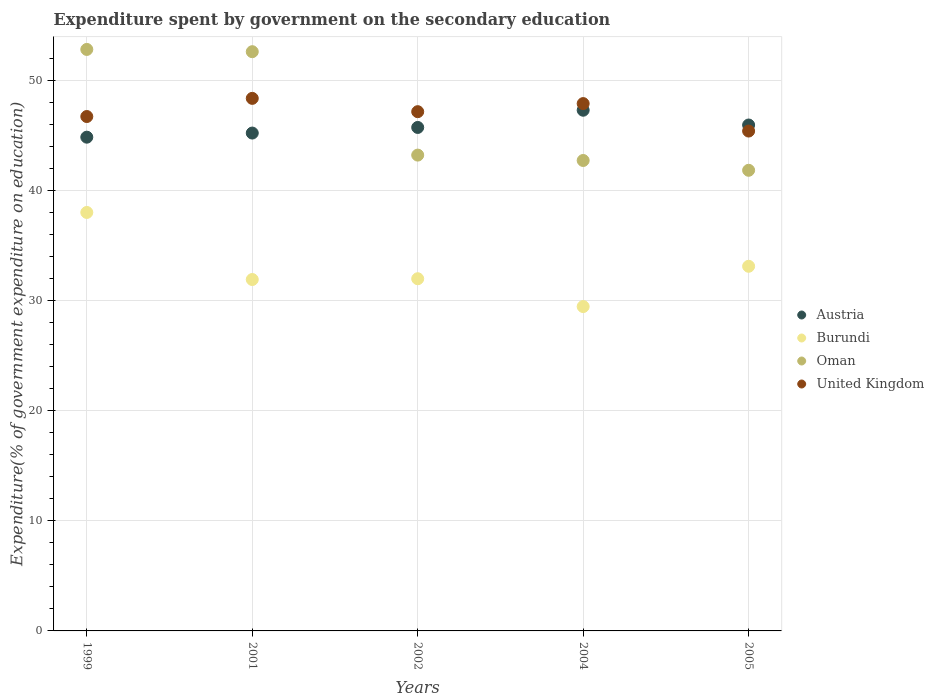How many different coloured dotlines are there?
Ensure brevity in your answer.  4. Is the number of dotlines equal to the number of legend labels?
Your answer should be very brief. Yes. What is the expenditure spent by government on the secondary education in United Kingdom in 2004?
Provide a short and direct response. 47.88. Across all years, what is the maximum expenditure spent by government on the secondary education in Burundi?
Offer a terse response. 38. Across all years, what is the minimum expenditure spent by government on the secondary education in United Kingdom?
Provide a succinct answer. 45.39. What is the total expenditure spent by government on the secondary education in Oman in the graph?
Provide a succinct answer. 233.14. What is the difference between the expenditure spent by government on the secondary education in Burundi in 2001 and that in 2005?
Provide a succinct answer. -1.2. What is the difference between the expenditure spent by government on the secondary education in Oman in 2002 and the expenditure spent by government on the secondary education in Austria in 2005?
Offer a terse response. -2.73. What is the average expenditure spent by government on the secondary education in United Kingdom per year?
Your answer should be very brief. 47.1. In the year 2005, what is the difference between the expenditure spent by government on the secondary education in Oman and expenditure spent by government on the secondary education in Austria?
Make the answer very short. -4.11. In how many years, is the expenditure spent by government on the secondary education in Burundi greater than 12 %?
Give a very brief answer. 5. What is the ratio of the expenditure spent by government on the secondary education in United Kingdom in 2001 to that in 2004?
Offer a terse response. 1.01. What is the difference between the highest and the second highest expenditure spent by government on the secondary education in United Kingdom?
Provide a short and direct response. 0.47. What is the difference between the highest and the lowest expenditure spent by government on the secondary education in Oman?
Give a very brief answer. 10.97. In how many years, is the expenditure spent by government on the secondary education in Burundi greater than the average expenditure spent by government on the secondary education in Burundi taken over all years?
Your answer should be very brief. 2. Is the sum of the expenditure spent by government on the secondary education in Austria in 1999 and 2005 greater than the maximum expenditure spent by government on the secondary education in Oman across all years?
Your answer should be compact. Yes. Is it the case that in every year, the sum of the expenditure spent by government on the secondary education in United Kingdom and expenditure spent by government on the secondary education in Burundi  is greater than the expenditure spent by government on the secondary education in Austria?
Give a very brief answer. Yes. Is the expenditure spent by government on the secondary education in Austria strictly greater than the expenditure spent by government on the secondary education in United Kingdom over the years?
Offer a terse response. No. Is the expenditure spent by government on the secondary education in Austria strictly less than the expenditure spent by government on the secondary education in Burundi over the years?
Your response must be concise. No. How many dotlines are there?
Give a very brief answer. 4. How many years are there in the graph?
Your answer should be very brief. 5. What is the difference between two consecutive major ticks on the Y-axis?
Make the answer very short. 10. Are the values on the major ticks of Y-axis written in scientific E-notation?
Your answer should be compact. No. Does the graph contain any zero values?
Offer a very short reply. No. Does the graph contain grids?
Offer a terse response. Yes. How many legend labels are there?
Your response must be concise. 4. How are the legend labels stacked?
Ensure brevity in your answer.  Vertical. What is the title of the graph?
Provide a succinct answer. Expenditure spent by government on the secondary education. What is the label or title of the X-axis?
Ensure brevity in your answer.  Years. What is the label or title of the Y-axis?
Make the answer very short. Expenditure(% of government expenditure on education). What is the Expenditure(% of government expenditure on education) of Austria in 1999?
Your answer should be compact. 44.83. What is the Expenditure(% of government expenditure on education) in Burundi in 1999?
Ensure brevity in your answer.  38. What is the Expenditure(% of government expenditure on education) in Oman in 1999?
Ensure brevity in your answer.  52.8. What is the Expenditure(% of government expenditure on education) in United Kingdom in 1999?
Offer a terse response. 46.71. What is the Expenditure(% of government expenditure on education) of Austria in 2001?
Keep it short and to the point. 45.21. What is the Expenditure(% of government expenditure on education) of Burundi in 2001?
Provide a succinct answer. 31.91. What is the Expenditure(% of government expenditure on education) of Oman in 2001?
Give a very brief answer. 52.59. What is the Expenditure(% of government expenditure on education) of United Kingdom in 2001?
Give a very brief answer. 48.36. What is the Expenditure(% of government expenditure on education) in Austria in 2002?
Your answer should be compact. 45.72. What is the Expenditure(% of government expenditure on education) of Burundi in 2002?
Offer a terse response. 31.98. What is the Expenditure(% of government expenditure on education) of Oman in 2002?
Ensure brevity in your answer.  43.21. What is the Expenditure(% of government expenditure on education) of United Kingdom in 2002?
Your response must be concise. 47.15. What is the Expenditure(% of government expenditure on education) in Austria in 2004?
Give a very brief answer. 47.28. What is the Expenditure(% of government expenditure on education) in Burundi in 2004?
Your answer should be compact. 29.45. What is the Expenditure(% of government expenditure on education) of Oman in 2004?
Offer a terse response. 42.72. What is the Expenditure(% of government expenditure on education) in United Kingdom in 2004?
Your response must be concise. 47.88. What is the Expenditure(% of government expenditure on education) of Austria in 2005?
Keep it short and to the point. 45.94. What is the Expenditure(% of government expenditure on education) of Burundi in 2005?
Ensure brevity in your answer.  33.11. What is the Expenditure(% of government expenditure on education) of Oman in 2005?
Your response must be concise. 41.83. What is the Expenditure(% of government expenditure on education) in United Kingdom in 2005?
Provide a short and direct response. 45.39. Across all years, what is the maximum Expenditure(% of government expenditure on education) of Austria?
Your response must be concise. 47.28. Across all years, what is the maximum Expenditure(% of government expenditure on education) in Burundi?
Offer a very short reply. 38. Across all years, what is the maximum Expenditure(% of government expenditure on education) in Oman?
Provide a short and direct response. 52.8. Across all years, what is the maximum Expenditure(% of government expenditure on education) in United Kingdom?
Make the answer very short. 48.36. Across all years, what is the minimum Expenditure(% of government expenditure on education) in Austria?
Your answer should be very brief. 44.83. Across all years, what is the minimum Expenditure(% of government expenditure on education) in Burundi?
Make the answer very short. 29.45. Across all years, what is the minimum Expenditure(% of government expenditure on education) in Oman?
Your answer should be very brief. 41.83. Across all years, what is the minimum Expenditure(% of government expenditure on education) of United Kingdom?
Ensure brevity in your answer.  45.39. What is the total Expenditure(% of government expenditure on education) of Austria in the graph?
Offer a very short reply. 228.97. What is the total Expenditure(% of government expenditure on education) in Burundi in the graph?
Your answer should be compact. 164.45. What is the total Expenditure(% of government expenditure on education) in Oman in the graph?
Ensure brevity in your answer.  233.14. What is the total Expenditure(% of government expenditure on education) of United Kingdom in the graph?
Your response must be concise. 235.48. What is the difference between the Expenditure(% of government expenditure on education) of Austria in 1999 and that in 2001?
Provide a short and direct response. -0.37. What is the difference between the Expenditure(% of government expenditure on education) of Burundi in 1999 and that in 2001?
Provide a succinct answer. 6.09. What is the difference between the Expenditure(% of government expenditure on education) of Oman in 1999 and that in 2001?
Your answer should be very brief. 0.21. What is the difference between the Expenditure(% of government expenditure on education) in United Kingdom in 1999 and that in 2001?
Your answer should be compact. -1.65. What is the difference between the Expenditure(% of government expenditure on education) in Austria in 1999 and that in 2002?
Make the answer very short. -0.88. What is the difference between the Expenditure(% of government expenditure on education) of Burundi in 1999 and that in 2002?
Your answer should be very brief. 6.02. What is the difference between the Expenditure(% of government expenditure on education) in Oman in 1999 and that in 2002?
Provide a short and direct response. 9.59. What is the difference between the Expenditure(% of government expenditure on education) in United Kingdom in 1999 and that in 2002?
Provide a succinct answer. -0.44. What is the difference between the Expenditure(% of government expenditure on education) in Austria in 1999 and that in 2004?
Give a very brief answer. -2.45. What is the difference between the Expenditure(% of government expenditure on education) in Burundi in 1999 and that in 2004?
Your response must be concise. 8.54. What is the difference between the Expenditure(% of government expenditure on education) in Oman in 1999 and that in 2004?
Your response must be concise. 10.08. What is the difference between the Expenditure(% of government expenditure on education) in United Kingdom in 1999 and that in 2004?
Keep it short and to the point. -1.17. What is the difference between the Expenditure(% of government expenditure on education) in Austria in 1999 and that in 2005?
Offer a very short reply. -1.1. What is the difference between the Expenditure(% of government expenditure on education) in Burundi in 1999 and that in 2005?
Your answer should be very brief. 4.89. What is the difference between the Expenditure(% of government expenditure on education) of Oman in 1999 and that in 2005?
Make the answer very short. 10.97. What is the difference between the Expenditure(% of government expenditure on education) of United Kingdom in 1999 and that in 2005?
Offer a very short reply. 1.32. What is the difference between the Expenditure(% of government expenditure on education) in Austria in 2001 and that in 2002?
Give a very brief answer. -0.51. What is the difference between the Expenditure(% of government expenditure on education) of Burundi in 2001 and that in 2002?
Provide a succinct answer. -0.07. What is the difference between the Expenditure(% of government expenditure on education) of Oman in 2001 and that in 2002?
Ensure brevity in your answer.  9.39. What is the difference between the Expenditure(% of government expenditure on education) of United Kingdom in 2001 and that in 2002?
Offer a very short reply. 1.21. What is the difference between the Expenditure(% of government expenditure on education) of Austria in 2001 and that in 2004?
Give a very brief answer. -2.07. What is the difference between the Expenditure(% of government expenditure on education) of Burundi in 2001 and that in 2004?
Keep it short and to the point. 2.46. What is the difference between the Expenditure(% of government expenditure on education) in Oman in 2001 and that in 2004?
Your response must be concise. 9.88. What is the difference between the Expenditure(% of government expenditure on education) in United Kingdom in 2001 and that in 2004?
Your answer should be compact. 0.47. What is the difference between the Expenditure(% of government expenditure on education) of Austria in 2001 and that in 2005?
Ensure brevity in your answer.  -0.73. What is the difference between the Expenditure(% of government expenditure on education) in Burundi in 2001 and that in 2005?
Offer a very short reply. -1.2. What is the difference between the Expenditure(% of government expenditure on education) of Oman in 2001 and that in 2005?
Your response must be concise. 10.77. What is the difference between the Expenditure(% of government expenditure on education) of United Kingdom in 2001 and that in 2005?
Your answer should be compact. 2.97. What is the difference between the Expenditure(% of government expenditure on education) of Austria in 2002 and that in 2004?
Offer a terse response. -1.56. What is the difference between the Expenditure(% of government expenditure on education) of Burundi in 2002 and that in 2004?
Give a very brief answer. 2.53. What is the difference between the Expenditure(% of government expenditure on education) of Oman in 2002 and that in 2004?
Offer a terse response. 0.49. What is the difference between the Expenditure(% of government expenditure on education) of United Kingdom in 2002 and that in 2004?
Your answer should be very brief. -0.73. What is the difference between the Expenditure(% of government expenditure on education) in Austria in 2002 and that in 2005?
Keep it short and to the point. -0.22. What is the difference between the Expenditure(% of government expenditure on education) of Burundi in 2002 and that in 2005?
Provide a short and direct response. -1.13. What is the difference between the Expenditure(% of government expenditure on education) of Oman in 2002 and that in 2005?
Your answer should be very brief. 1.38. What is the difference between the Expenditure(% of government expenditure on education) of United Kingdom in 2002 and that in 2005?
Offer a very short reply. 1.76. What is the difference between the Expenditure(% of government expenditure on education) in Austria in 2004 and that in 2005?
Ensure brevity in your answer.  1.34. What is the difference between the Expenditure(% of government expenditure on education) in Burundi in 2004 and that in 2005?
Provide a short and direct response. -3.66. What is the difference between the Expenditure(% of government expenditure on education) of Oman in 2004 and that in 2005?
Your answer should be compact. 0.89. What is the difference between the Expenditure(% of government expenditure on education) of United Kingdom in 2004 and that in 2005?
Ensure brevity in your answer.  2.49. What is the difference between the Expenditure(% of government expenditure on education) in Austria in 1999 and the Expenditure(% of government expenditure on education) in Burundi in 2001?
Make the answer very short. 12.92. What is the difference between the Expenditure(% of government expenditure on education) of Austria in 1999 and the Expenditure(% of government expenditure on education) of Oman in 2001?
Offer a terse response. -7.76. What is the difference between the Expenditure(% of government expenditure on education) in Austria in 1999 and the Expenditure(% of government expenditure on education) in United Kingdom in 2001?
Offer a very short reply. -3.52. What is the difference between the Expenditure(% of government expenditure on education) in Burundi in 1999 and the Expenditure(% of government expenditure on education) in Oman in 2001?
Your answer should be compact. -14.6. What is the difference between the Expenditure(% of government expenditure on education) in Burundi in 1999 and the Expenditure(% of government expenditure on education) in United Kingdom in 2001?
Provide a short and direct response. -10.36. What is the difference between the Expenditure(% of government expenditure on education) in Oman in 1999 and the Expenditure(% of government expenditure on education) in United Kingdom in 2001?
Give a very brief answer. 4.44. What is the difference between the Expenditure(% of government expenditure on education) in Austria in 1999 and the Expenditure(% of government expenditure on education) in Burundi in 2002?
Make the answer very short. 12.85. What is the difference between the Expenditure(% of government expenditure on education) of Austria in 1999 and the Expenditure(% of government expenditure on education) of Oman in 2002?
Provide a short and direct response. 1.63. What is the difference between the Expenditure(% of government expenditure on education) in Austria in 1999 and the Expenditure(% of government expenditure on education) in United Kingdom in 2002?
Your response must be concise. -2.32. What is the difference between the Expenditure(% of government expenditure on education) in Burundi in 1999 and the Expenditure(% of government expenditure on education) in Oman in 2002?
Your answer should be very brief. -5.21. What is the difference between the Expenditure(% of government expenditure on education) in Burundi in 1999 and the Expenditure(% of government expenditure on education) in United Kingdom in 2002?
Make the answer very short. -9.15. What is the difference between the Expenditure(% of government expenditure on education) of Oman in 1999 and the Expenditure(% of government expenditure on education) of United Kingdom in 2002?
Make the answer very short. 5.65. What is the difference between the Expenditure(% of government expenditure on education) of Austria in 1999 and the Expenditure(% of government expenditure on education) of Burundi in 2004?
Give a very brief answer. 15.38. What is the difference between the Expenditure(% of government expenditure on education) in Austria in 1999 and the Expenditure(% of government expenditure on education) in Oman in 2004?
Offer a very short reply. 2.12. What is the difference between the Expenditure(% of government expenditure on education) of Austria in 1999 and the Expenditure(% of government expenditure on education) of United Kingdom in 2004?
Your answer should be very brief. -3.05. What is the difference between the Expenditure(% of government expenditure on education) in Burundi in 1999 and the Expenditure(% of government expenditure on education) in Oman in 2004?
Offer a terse response. -4.72. What is the difference between the Expenditure(% of government expenditure on education) of Burundi in 1999 and the Expenditure(% of government expenditure on education) of United Kingdom in 2004?
Provide a short and direct response. -9.88. What is the difference between the Expenditure(% of government expenditure on education) of Oman in 1999 and the Expenditure(% of government expenditure on education) of United Kingdom in 2004?
Provide a short and direct response. 4.92. What is the difference between the Expenditure(% of government expenditure on education) of Austria in 1999 and the Expenditure(% of government expenditure on education) of Burundi in 2005?
Give a very brief answer. 11.72. What is the difference between the Expenditure(% of government expenditure on education) in Austria in 1999 and the Expenditure(% of government expenditure on education) in Oman in 2005?
Keep it short and to the point. 3.01. What is the difference between the Expenditure(% of government expenditure on education) of Austria in 1999 and the Expenditure(% of government expenditure on education) of United Kingdom in 2005?
Offer a terse response. -0.56. What is the difference between the Expenditure(% of government expenditure on education) of Burundi in 1999 and the Expenditure(% of government expenditure on education) of Oman in 2005?
Keep it short and to the point. -3.83. What is the difference between the Expenditure(% of government expenditure on education) of Burundi in 1999 and the Expenditure(% of government expenditure on education) of United Kingdom in 2005?
Provide a succinct answer. -7.39. What is the difference between the Expenditure(% of government expenditure on education) in Oman in 1999 and the Expenditure(% of government expenditure on education) in United Kingdom in 2005?
Provide a succinct answer. 7.41. What is the difference between the Expenditure(% of government expenditure on education) of Austria in 2001 and the Expenditure(% of government expenditure on education) of Burundi in 2002?
Your answer should be compact. 13.23. What is the difference between the Expenditure(% of government expenditure on education) of Austria in 2001 and the Expenditure(% of government expenditure on education) of Oman in 2002?
Provide a short and direct response. 2. What is the difference between the Expenditure(% of government expenditure on education) in Austria in 2001 and the Expenditure(% of government expenditure on education) in United Kingdom in 2002?
Offer a terse response. -1.94. What is the difference between the Expenditure(% of government expenditure on education) of Burundi in 2001 and the Expenditure(% of government expenditure on education) of Oman in 2002?
Ensure brevity in your answer.  -11.3. What is the difference between the Expenditure(% of government expenditure on education) of Burundi in 2001 and the Expenditure(% of government expenditure on education) of United Kingdom in 2002?
Provide a short and direct response. -15.24. What is the difference between the Expenditure(% of government expenditure on education) in Oman in 2001 and the Expenditure(% of government expenditure on education) in United Kingdom in 2002?
Your response must be concise. 5.45. What is the difference between the Expenditure(% of government expenditure on education) in Austria in 2001 and the Expenditure(% of government expenditure on education) in Burundi in 2004?
Give a very brief answer. 15.75. What is the difference between the Expenditure(% of government expenditure on education) of Austria in 2001 and the Expenditure(% of government expenditure on education) of Oman in 2004?
Make the answer very short. 2.49. What is the difference between the Expenditure(% of government expenditure on education) in Austria in 2001 and the Expenditure(% of government expenditure on education) in United Kingdom in 2004?
Your response must be concise. -2.68. What is the difference between the Expenditure(% of government expenditure on education) of Burundi in 2001 and the Expenditure(% of government expenditure on education) of Oman in 2004?
Your answer should be compact. -10.81. What is the difference between the Expenditure(% of government expenditure on education) in Burundi in 2001 and the Expenditure(% of government expenditure on education) in United Kingdom in 2004?
Provide a succinct answer. -15.97. What is the difference between the Expenditure(% of government expenditure on education) of Oman in 2001 and the Expenditure(% of government expenditure on education) of United Kingdom in 2004?
Make the answer very short. 4.71. What is the difference between the Expenditure(% of government expenditure on education) in Austria in 2001 and the Expenditure(% of government expenditure on education) in Burundi in 2005?
Offer a terse response. 12.1. What is the difference between the Expenditure(% of government expenditure on education) of Austria in 2001 and the Expenditure(% of government expenditure on education) of Oman in 2005?
Your answer should be very brief. 3.38. What is the difference between the Expenditure(% of government expenditure on education) of Austria in 2001 and the Expenditure(% of government expenditure on education) of United Kingdom in 2005?
Make the answer very short. -0.18. What is the difference between the Expenditure(% of government expenditure on education) of Burundi in 2001 and the Expenditure(% of government expenditure on education) of Oman in 2005?
Provide a short and direct response. -9.92. What is the difference between the Expenditure(% of government expenditure on education) of Burundi in 2001 and the Expenditure(% of government expenditure on education) of United Kingdom in 2005?
Give a very brief answer. -13.48. What is the difference between the Expenditure(% of government expenditure on education) in Oman in 2001 and the Expenditure(% of government expenditure on education) in United Kingdom in 2005?
Your answer should be compact. 7.21. What is the difference between the Expenditure(% of government expenditure on education) of Austria in 2002 and the Expenditure(% of government expenditure on education) of Burundi in 2004?
Offer a terse response. 16.26. What is the difference between the Expenditure(% of government expenditure on education) of Austria in 2002 and the Expenditure(% of government expenditure on education) of Oman in 2004?
Keep it short and to the point. 3. What is the difference between the Expenditure(% of government expenditure on education) in Austria in 2002 and the Expenditure(% of government expenditure on education) in United Kingdom in 2004?
Give a very brief answer. -2.17. What is the difference between the Expenditure(% of government expenditure on education) in Burundi in 2002 and the Expenditure(% of government expenditure on education) in Oman in 2004?
Make the answer very short. -10.74. What is the difference between the Expenditure(% of government expenditure on education) of Burundi in 2002 and the Expenditure(% of government expenditure on education) of United Kingdom in 2004?
Keep it short and to the point. -15.9. What is the difference between the Expenditure(% of government expenditure on education) in Oman in 2002 and the Expenditure(% of government expenditure on education) in United Kingdom in 2004?
Keep it short and to the point. -4.68. What is the difference between the Expenditure(% of government expenditure on education) in Austria in 2002 and the Expenditure(% of government expenditure on education) in Burundi in 2005?
Your answer should be compact. 12.61. What is the difference between the Expenditure(% of government expenditure on education) of Austria in 2002 and the Expenditure(% of government expenditure on education) of Oman in 2005?
Give a very brief answer. 3.89. What is the difference between the Expenditure(% of government expenditure on education) of Austria in 2002 and the Expenditure(% of government expenditure on education) of United Kingdom in 2005?
Provide a short and direct response. 0.33. What is the difference between the Expenditure(% of government expenditure on education) of Burundi in 2002 and the Expenditure(% of government expenditure on education) of Oman in 2005?
Give a very brief answer. -9.85. What is the difference between the Expenditure(% of government expenditure on education) of Burundi in 2002 and the Expenditure(% of government expenditure on education) of United Kingdom in 2005?
Provide a succinct answer. -13.41. What is the difference between the Expenditure(% of government expenditure on education) in Oman in 2002 and the Expenditure(% of government expenditure on education) in United Kingdom in 2005?
Make the answer very short. -2.18. What is the difference between the Expenditure(% of government expenditure on education) in Austria in 2004 and the Expenditure(% of government expenditure on education) in Burundi in 2005?
Make the answer very short. 14.17. What is the difference between the Expenditure(% of government expenditure on education) of Austria in 2004 and the Expenditure(% of government expenditure on education) of Oman in 2005?
Your response must be concise. 5.45. What is the difference between the Expenditure(% of government expenditure on education) in Austria in 2004 and the Expenditure(% of government expenditure on education) in United Kingdom in 2005?
Offer a terse response. 1.89. What is the difference between the Expenditure(% of government expenditure on education) in Burundi in 2004 and the Expenditure(% of government expenditure on education) in Oman in 2005?
Keep it short and to the point. -12.37. What is the difference between the Expenditure(% of government expenditure on education) of Burundi in 2004 and the Expenditure(% of government expenditure on education) of United Kingdom in 2005?
Ensure brevity in your answer.  -15.94. What is the difference between the Expenditure(% of government expenditure on education) in Oman in 2004 and the Expenditure(% of government expenditure on education) in United Kingdom in 2005?
Offer a terse response. -2.67. What is the average Expenditure(% of government expenditure on education) of Austria per year?
Give a very brief answer. 45.79. What is the average Expenditure(% of government expenditure on education) of Burundi per year?
Your answer should be compact. 32.89. What is the average Expenditure(% of government expenditure on education) in Oman per year?
Ensure brevity in your answer.  46.63. What is the average Expenditure(% of government expenditure on education) in United Kingdom per year?
Offer a terse response. 47.1. In the year 1999, what is the difference between the Expenditure(% of government expenditure on education) of Austria and Expenditure(% of government expenditure on education) of Burundi?
Give a very brief answer. 6.84. In the year 1999, what is the difference between the Expenditure(% of government expenditure on education) in Austria and Expenditure(% of government expenditure on education) in Oman?
Give a very brief answer. -7.97. In the year 1999, what is the difference between the Expenditure(% of government expenditure on education) of Austria and Expenditure(% of government expenditure on education) of United Kingdom?
Provide a succinct answer. -1.88. In the year 1999, what is the difference between the Expenditure(% of government expenditure on education) of Burundi and Expenditure(% of government expenditure on education) of Oman?
Make the answer very short. -14.8. In the year 1999, what is the difference between the Expenditure(% of government expenditure on education) of Burundi and Expenditure(% of government expenditure on education) of United Kingdom?
Make the answer very short. -8.71. In the year 1999, what is the difference between the Expenditure(% of government expenditure on education) in Oman and Expenditure(% of government expenditure on education) in United Kingdom?
Provide a succinct answer. 6.09. In the year 2001, what is the difference between the Expenditure(% of government expenditure on education) in Austria and Expenditure(% of government expenditure on education) in Burundi?
Offer a terse response. 13.3. In the year 2001, what is the difference between the Expenditure(% of government expenditure on education) of Austria and Expenditure(% of government expenditure on education) of Oman?
Provide a short and direct response. -7.39. In the year 2001, what is the difference between the Expenditure(% of government expenditure on education) of Austria and Expenditure(% of government expenditure on education) of United Kingdom?
Your answer should be very brief. -3.15. In the year 2001, what is the difference between the Expenditure(% of government expenditure on education) of Burundi and Expenditure(% of government expenditure on education) of Oman?
Ensure brevity in your answer.  -20.69. In the year 2001, what is the difference between the Expenditure(% of government expenditure on education) in Burundi and Expenditure(% of government expenditure on education) in United Kingdom?
Your answer should be compact. -16.45. In the year 2001, what is the difference between the Expenditure(% of government expenditure on education) of Oman and Expenditure(% of government expenditure on education) of United Kingdom?
Your answer should be very brief. 4.24. In the year 2002, what is the difference between the Expenditure(% of government expenditure on education) of Austria and Expenditure(% of government expenditure on education) of Burundi?
Keep it short and to the point. 13.74. In the year 2002, what is the difference between the Expenditure(% of government expenditure on education) in Austria and Expenditure(% of government expenditure on education) in Oman?
Your response must be concise. 2.51. In the year 2002, what is the difference between the Expenditure(% of government expenditure on education) of Austria and Expenditure(% of government expenditure on education) of United Kingdom?
Provide a succinct answer. -1.43. In the year 2002, what is the difference between the Expenditure(% of government expenditure on education) of Burundi and Expenditure(% of government expenditure on education) of Oman?
Your answer should be compact. -11.23. In the year 2002, what is the difference between the Expenditure(% of government expenditure on education) in Burundi and Expenditure(% of government expenditure on education) in United Kingdom?
Offer a terse response. -15.17. In the year 2002, what is the difference between the Expenditure(% of government expenditure on education) of Oman and Expenditure(% of government expenditure on education) of United Kingdom?
Your answer should be very brief. -3.94. In the year 2004, what is the difference between the Expenditure(% of government expenditure on education) of Austria and Expenditure(% of government expenditure on education) of Burundi?
Give a very brief answer. 17.83. In the year 2004, what is the difference between the Expenditure(% of government expenditure on education) in Austria and Expenditure(% of government expenditure on education) in Oman?
Provide a succinct answer. 4.56. In the year 2004, what is the difference between the Expenditure(% of government expenditure on education) in Austria and Expenditure(% of government expenditure on education) in United Kingdom?
Offer a terse response. -0.6. In the year 2004, what is the difference between the Expenditure(% of government expenditure on education) of Burundi and Expenditure(% of government expenditure on education) of Oman?
Provide a succinct answer. -13.26. In the year 2004, what is the difference between the Expenditure(% of government expenditure on education) of Burundi and Expenditure(% of government expenditure on education) of United Kingdom?
Your answer should be very brief. -18.43. In the year 2004, what is the difference between the Expenditure(% of government expenditure on education) in Oman and Expenditure(% of government expenditure on education) in United Kingdom?
Your answer should be compact. -5.17. In the year 2005, what is the difference between the Expenditure(% of government expenditure on education) in Austria and Expenditure(% of government expenditure on education) in Burundi?
Provide a short and direct response. 12.83. In the year 2005, what is the difference between the Expenditure(% of government expenditure on education) of Austria and Expenditure(% of government expenditure on education) of Oman?
Ensure brevity in your answer.  4.11. In the year 2005, what is the difference between the Expenditure(% of government expenditure on education) of Austria and Expenditure(% of government expenditure on education) of United Kingdom?
Keep it short and to the point. 0.55. In the year 2005, what is the difference between the Expenditure(% of government expenditure on education) of Burundi and Expenditure(% of government expenditure on education) of Oman?
Make the answer very short. -8.72. In the year 2005, what is the difference between the Expenditure(% of government expenditure on education) of Burundi and Expenditure(% of government expenditure on education) of United Kingdom?
Your answer should be very brief. -12.28. In the year 2005, what is the difference between the Expenditure(% of government expenditure on education) in Oman and Expenditure(% of government expenditure on education) in United Kingdom?
Keep it short and to the point. -3.56. What is the ratio of the Expenditure(% of government expenditure on education) in Austria in 1999 to that in 2001?
Give a very brief answer. 0.99. What is the ratio of the Expenditure(% of government expenditure on education) in Burundi in 1999 to that in 2001?
Provide a short and direct response. 1.19. What is the ratio of the Expenditure(% of government expenditure on education) in Oman in 1999 to that in 2001?
Offer a terse response. 1. What is the ratio of the Expenditure(% of government expenditure on education) of United Kingdom in 1999 to that in 2001?
Provide a succinct answer. 0.97. What is the ratio of the Expenditure(% of government expenditure on education) of Austria in 1999 to that in 2002?
Offer a very short reply. 0.98. What is the ratio of the Expenditure(% of government expenditure on education) in Burundi in 1999 to that in 2002?
Offer a terse response. 1.19. What is the ratio of the Expenditure(% of government expenditure on education) in Oman in 1999 to that in 2002?
Offer a terse response. 1.22. What is the ratio of the Expenditure(% of government expenditure on education) in Austria in 1999 to that in 2004?
Provide a short and direct response. 0.95. What is the ratio of the Expenditure(% of government expenditure on education) in Burundi in 1999 to that in 2004?
Ensure brevity in your answer.  1.29. What is the ratio of the Expenditure(% of government expenditure on education) of Oman in 1999 to that in 2004?
Your answer should be very brief. 1.24. What is the ratio of the Expenditure(% of government expenditure on education) of United Kingdom in 1999 to that in 2004?
Ensure brevity in your answer.  0.98. What is the ratio of the Expenditure(% of government expenditure on education) of Austria in 1999 to that in 2005?
Provide a succinct answer. 0.98. What is the ratio of the Expenditure(% of government expenditure on education) of Burundi in 1999 to that in 2005?
Keep it short and to the point. 1.15. What is the ratio of the Expenditure(% of government expenditure on education) in Oman in 1999 to that in 2005?
Offer a very short reply. 1.26. What is the ratio of the Expenditure(% of government expenditure on education) in United Kingdom in 1999 to that in 2005?
Give a very brief answer. 1.03. What is the ratio of the Expenditure(% of government expenditure on education) in Oman in 2001 to that in 2002?
Offer a terse response. 1.22. What is the ratio of the Expenditure(% of government expenditure on education) of United Kingdom in 2001 to that in 2002?
Offer a very short reply. 1.03. What is the ratio of the Expenditure(% of government expenditure on education) of Austria in 2001 to that in 2004?
Ensure brevity in your answer.  0.96. What is the ratio of the Expenditure(% of government expenditure on education) of Burundi in 2001 to that in 2004?
Your answer should be compact. 1.08. What is the ratio of the Expenditure(% of government expenditure on education) of Oman in 2001 to that in 2004?
Offer a very short reply. 1.23. What is the ratio of the Expenditure(% of government expenditure on education) of United Kingdom in 2001 to that in 2004?
Your answer should be compact. 1.01. What is the ratio of the Expenditure(% of government expenditure on education) of Austria in 2001 to that in 2005?
Offer a very short reply. 0.98. What is the ratio of the Expenditure(% of government expenditure on education) in Burundi in 2001 to that in 2005?
Offer a terse response. 0.96. What is the ratio of the Expenditure(% of government expenditure on education) of Oman in 2001 to that in 2005?
Your answer should be compact. 1.26. What is the ratio of the Expenditure(% of government expenditure on education) in United Kingdom in 2001 to that in 2005?
Make the answer very short. 1.07. What is the ratio of the Expenditure(% of government expenditure on education) in Austria in 2002 to that in 2004?
Offer a terse response. 0.97. What is the ratio of the Expenditure(% of government expenditure on education) of Burundi in 2002 to that in 2004?
Your answer should be compact. 1.09. What is the ratio of the Expenditure(% of government expenditure on education) of Oman in 2002 to that in 2004?
Provide a short and direct response. 1.01. What is the ratio of the Expenditure(% of government expenditure on education) of United Kingdom in 2002 to that in 2004?
Offer a terse response. 0.98. What is the ratio of the Expenditure(% of government expenditure on education) of Burundi in 2002 to that in 2005?
Your response must be concise. 0.97. What is the ratio of the Expenditure(% of government expenditure on education) of Oman in 2002 to that in 2005?
Give a very brief answer. 1.03. What is the ratio of the Expenditure(% of government expenditure on education) of United Kingdom in 2002 to that in 2005?
Offer a terse response. 1.04. What is the ratio of the Expenditure(% of government expenditure on education) of Austria in 2004 to that in 2005?
Offer a very short reply. 1.03. What is the ratio of the Expenditure(% of government expenditure on education) of Burundi in 2004 to that in 2005?
Offer a terse response. 0.89. What is the ratio of the Expenditure(% of government expenditure on education) in Oman in 2004 to that in 2005?
Make the answer very short. 1.02. What is the ratio of the Expenditure(% of government expenditure on education) of United Kingdom in 2004 to that in 2005?
Offer a terse response. 1.05. What is the difference between the highest and the second highest Expenditure(% of government expenditure on education) of Austria?
Ensure brevity in your answer.  1.34. What is the difference between the highest and the second highest Expenditure(% of government expenditure on education) in Burundi?
Provide a succinct answer. 4.89. What is the difference between the highest and the second highest Expenditure(% of government expenditure on education) of Oman?
Your answer should be very brief. 0.21. What is the difference between the highest and the second highest Expenditure(% of government expenditure on education) of United Kingdom?
Your response must be concise. 0.47. What is the difference between the highest and the lowest Expenditure(% of government expenditure on education) in Austria?
Ensure brevity in your answer.  2.45. What is the difference between the highest and the lowest Expenditure(% of government expenditure on education) of Burundi?
Make the answer very short. 8.54. What is the difference between the highest and the lowest Expenditure(% of government expenditure on education) of Oman?
Offer a very short reply. 10.97. What is the difference between the highest and the lowest Expenditure(% of government expenditure on education) in United Kingdom?
Give a very brief answer. 2.97. 